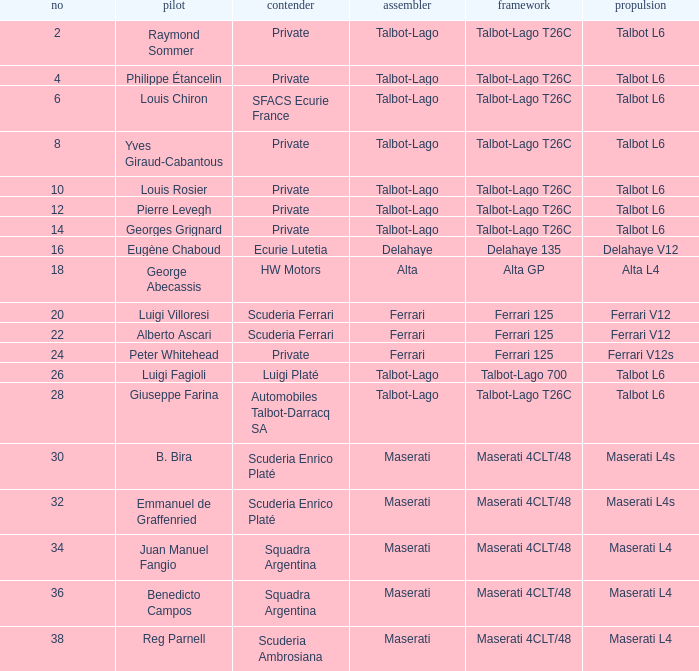Name the chassis for sfacs ecurie france Talbot-Lago T26C. 